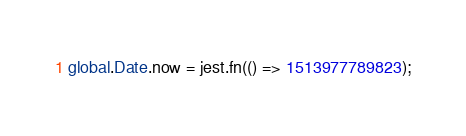<code> <loc_0><loc_0><loc_500><loc_500><_JavaScript_>global.Date.now = jest.fn(() => 1513977789823);
</code> 